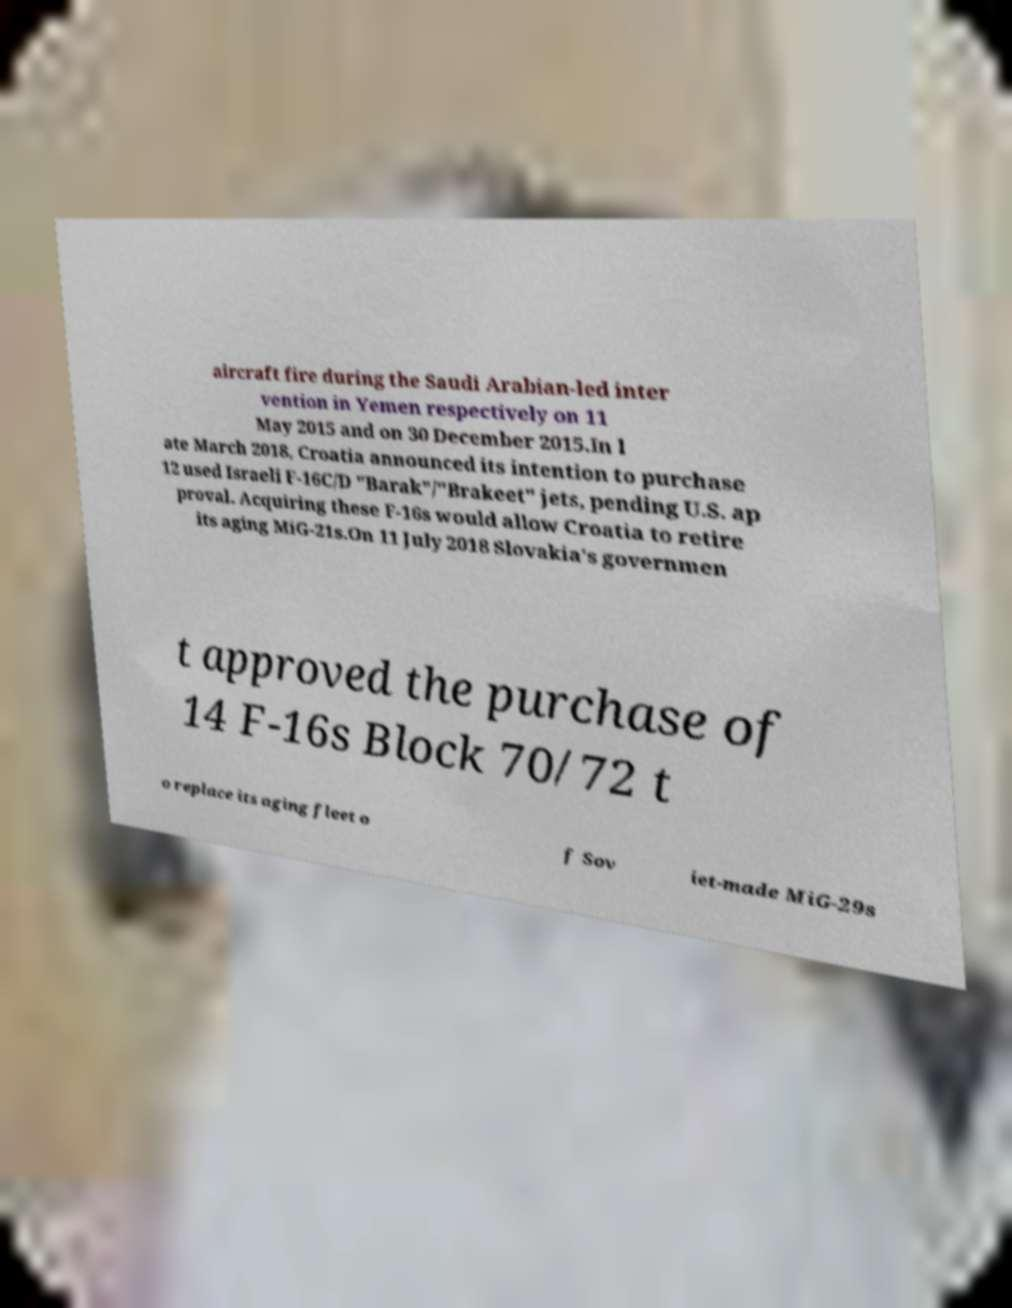Can you read and provide the text displayed in the image?This photo seems to have some interesting text. Can you extract and type it out for me? aircraft fire during the Saudi Arabian-led inter vention in Yemen respectively on 11 May 2015 and on 30 December 2015.In l ate March 2018, Croatia announced its intention to purchase 12 used Israeli F-16C/D "Barak"/"Brakeet" jets, pending U.S. ap proval. Acquiring these F-16s would allow Croatia to retire its aging MiG-21s.On 11 July 2018 Slovakia's governmen t approved the purchase of 14 F-16s Block 70/72 t o replace its aging fleet o f Sov iet-made MiG-29s 